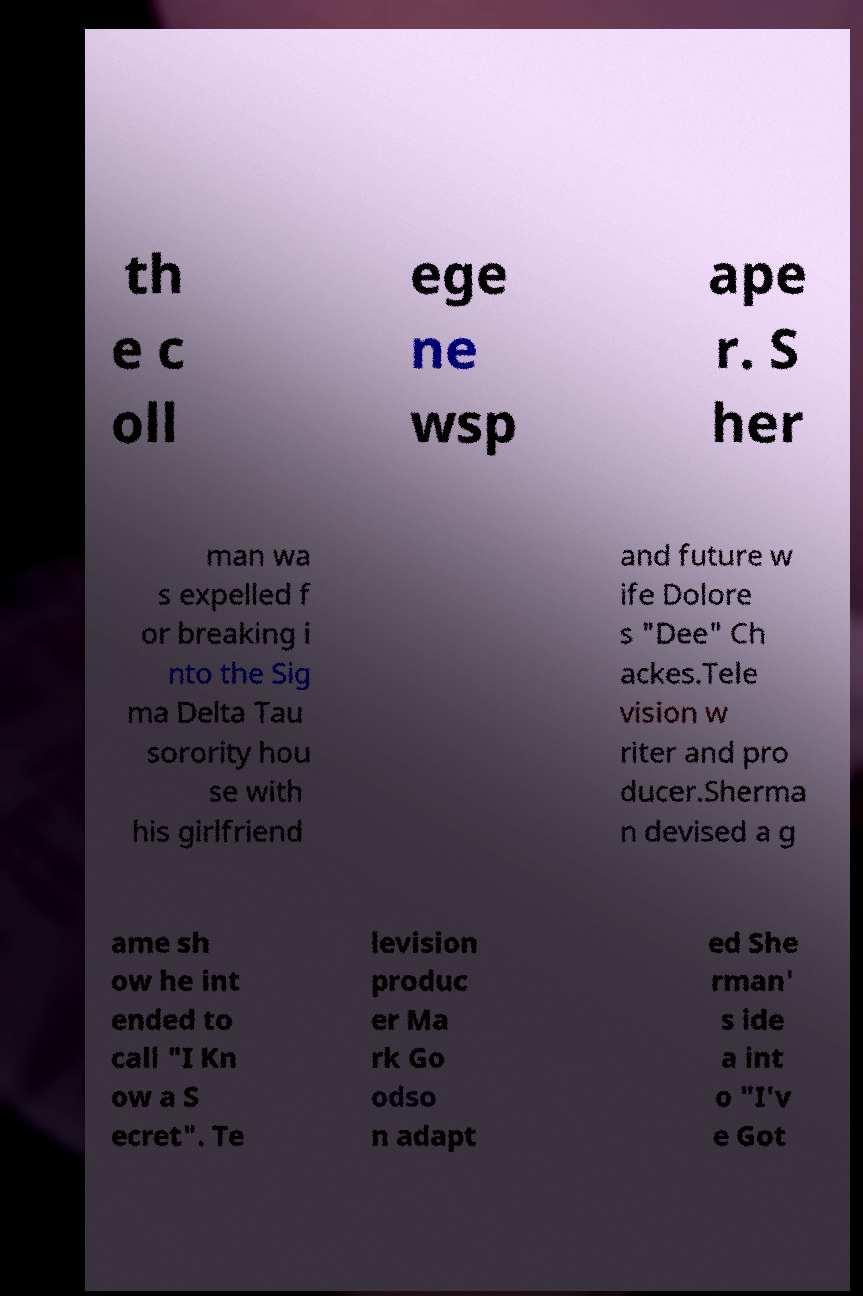I need the written content from this picture converted into text. Can you do that? th e c oll ege ne wsp ape r. S her man wa s expelled f or breaking i nto the Sig ma Delta Tau sorority hou se with his girlfriend and future w ife Dolore s "Dee" Ch ackes.Tele vision w riter and pro ducer.Sherma n devised a g ame sh ow he int ended to call "I Kn ow a S ecret". Te levision produc er Ma rk Go odso n adapt ed She rman' s ide a int o "I'v e Got 